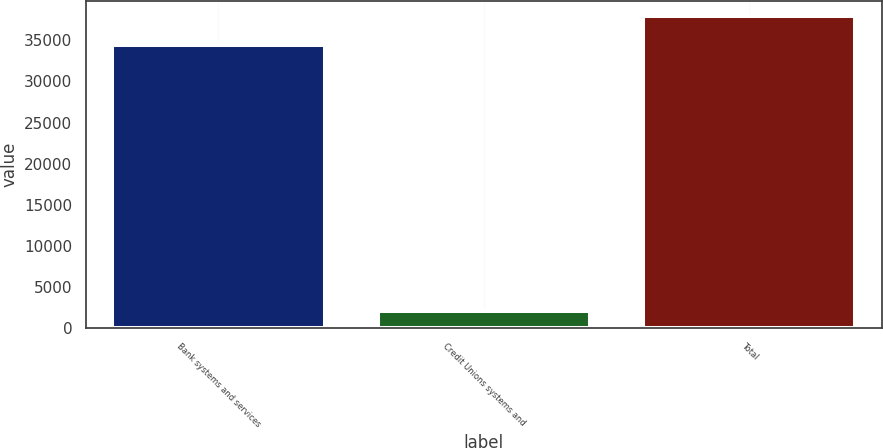Convert chart to OTSL. <chart><loc_0><loc_0><loc_500><loc_500><bar_chart><fcel>Bank systems and services<fcel>Credit Unions systems and<fcel>Total<nl><fcel>34497<fcel>2092<fcel>37946.7<nl></chart> 